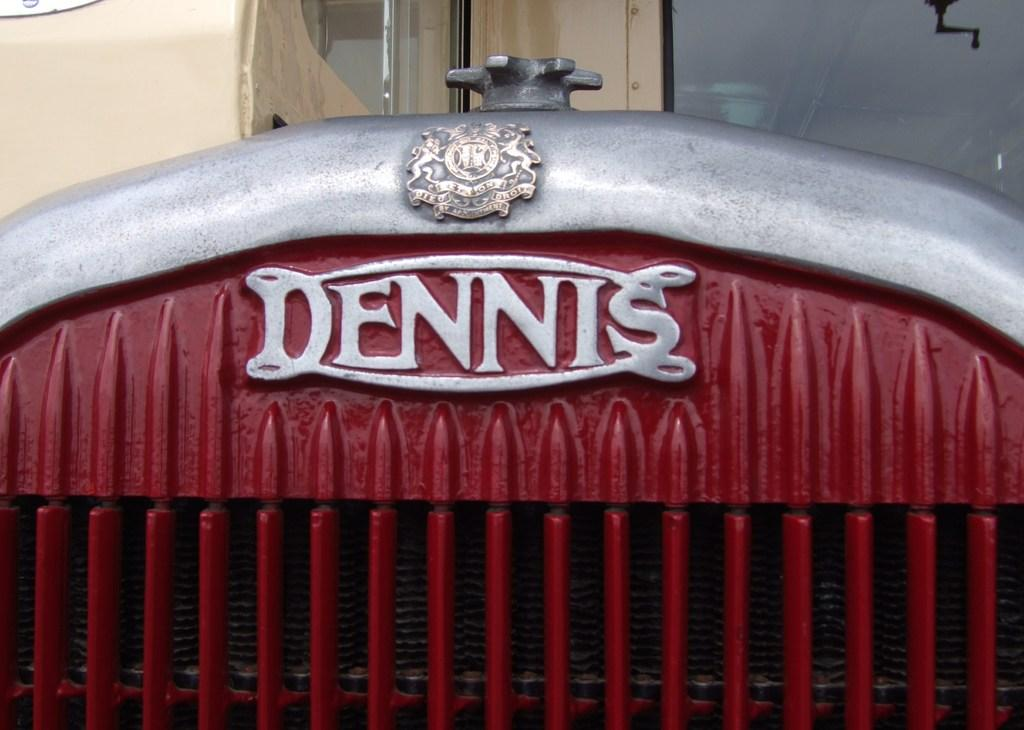What type of object with text is visible in the image? There is a metal object with text in the image. What is the material of the wall in the image? The wall in the image has glass. Can you describe the object located in the top left corner of the image? Unfortunately, the facts provided do not give any information about the object in the top left corner of the image. What type of body is visible in the image? There is no body present in the image. What type of amusement can be seen in the image? There is no amusement present in the image. 